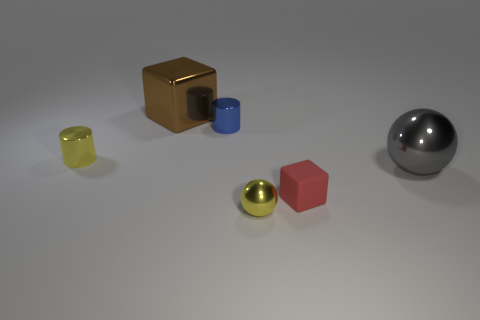Is there any other thing that has the same material as the tiny red cube?
Provide a short and direct response. No. Are there any matte objects that have the same size as the blue metallic object?
Offer a very short reply. Yes. What number of other things are made of the same material as the yellow cylinder?
Provide a succinct answer. 4. There is a metallic object that is both to the right of the blue shiny cylinder and left of the gray shiny ball; what color is it?
Ensure brevity in your answer.  Yellow. Does the tiny yellow thing on the right side of the brown metal thing have the same material as the yellow cylinder that is behind the gray object?
Offer a very short reply. Yes. There is a cylinder that is right of the brown cube; does it have the same size as the small red thing?
Give a very brief answer. Yes. There is a tiny metal sphere; is its color the same as the cube that is behind the large metallic sphere?
Make the answer very short. No. What shape is the red thing?
Give a very brief answer. Cube. Does the big cube have the same color as the tiny metal ball?
Your answer should be very brief. No. What number of objects are objects that are on the right side of the brown metallic block or tiny blue things?
Offer a terse response. 4. 